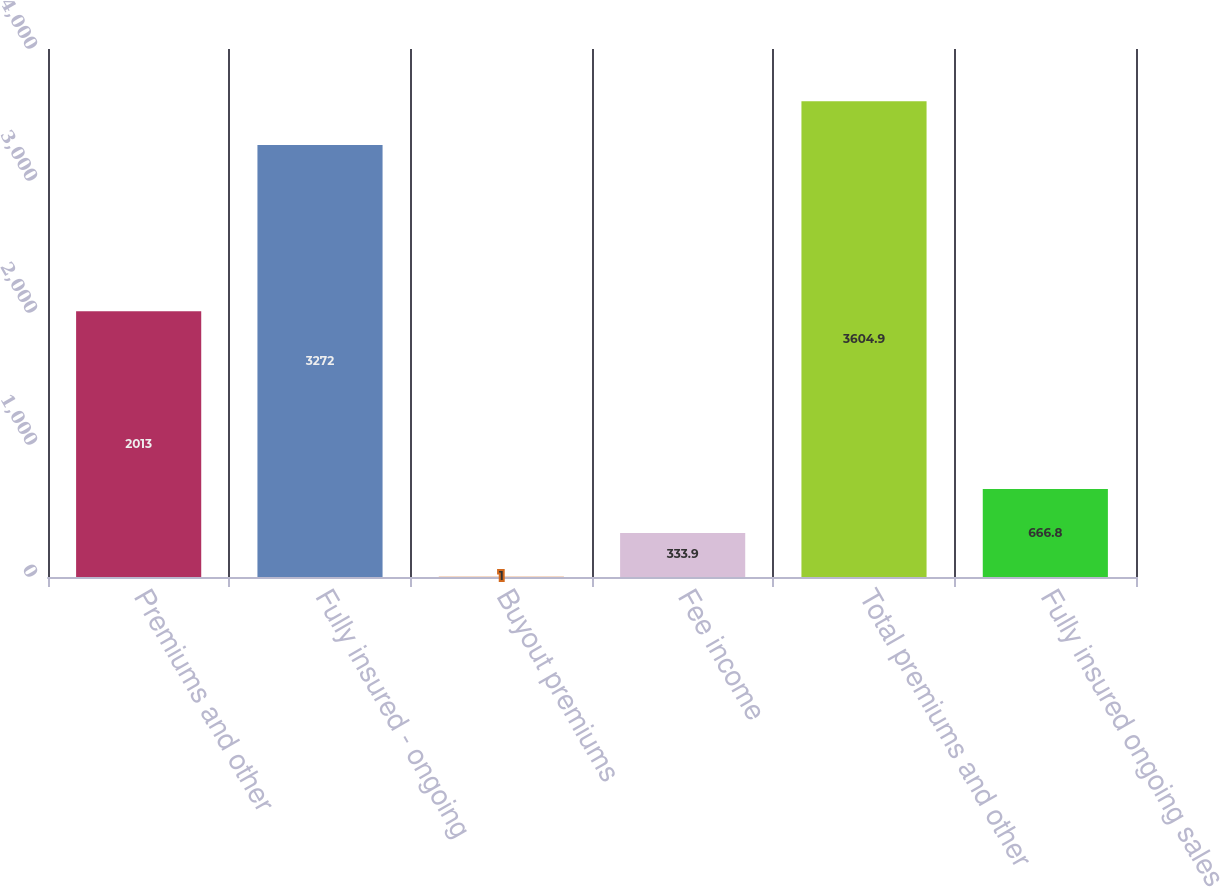Convert chart to OTSL. <chart><loc_0><loc_0><loc_500><loc_500><bar_chart><fcel>Premiums and other<fcel>Fully insured - ongoing<fcel>Buyout premiums<fcel>Fee income<fcel>Total premiums and other<fcel>Fully insured ongoing sales<nl><fcel>2013<fcel>3272<fcel>1<fcel>333.9<fcel>3604.9<fcel>666.8<nl></chart> 